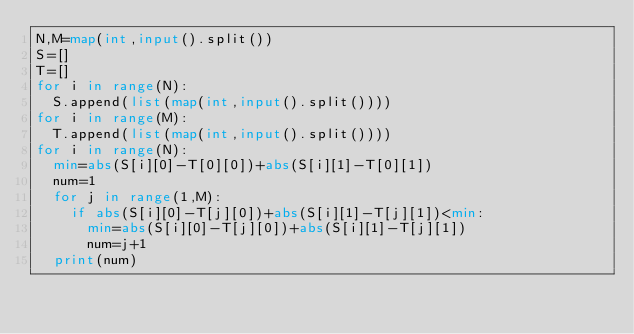Convert code to text. <code><loc_0><loc_0><loc_500><loc_500><_Python_>N,M=map(int,input().split())
S=[]
T=[]
for i in range(N):
  S.append(list(map(int,input().split())))
for i in range(M):
  T.append(list(map(int,input().split())))
for i in range(N):
  min=abs(S[i][0]-T[0][0])+abs(S[i][1]-T[0][1])
  num=1
  for j in range(1,M):
    if abs(S[i][0]-T[j][0])+abs(S[i][1]-T[j][1])<min:
      min=abs(S[i][0]-T[j][0])+abs(S[i][1]-T[j][1])
      num=j+1
  print(num)</code> 